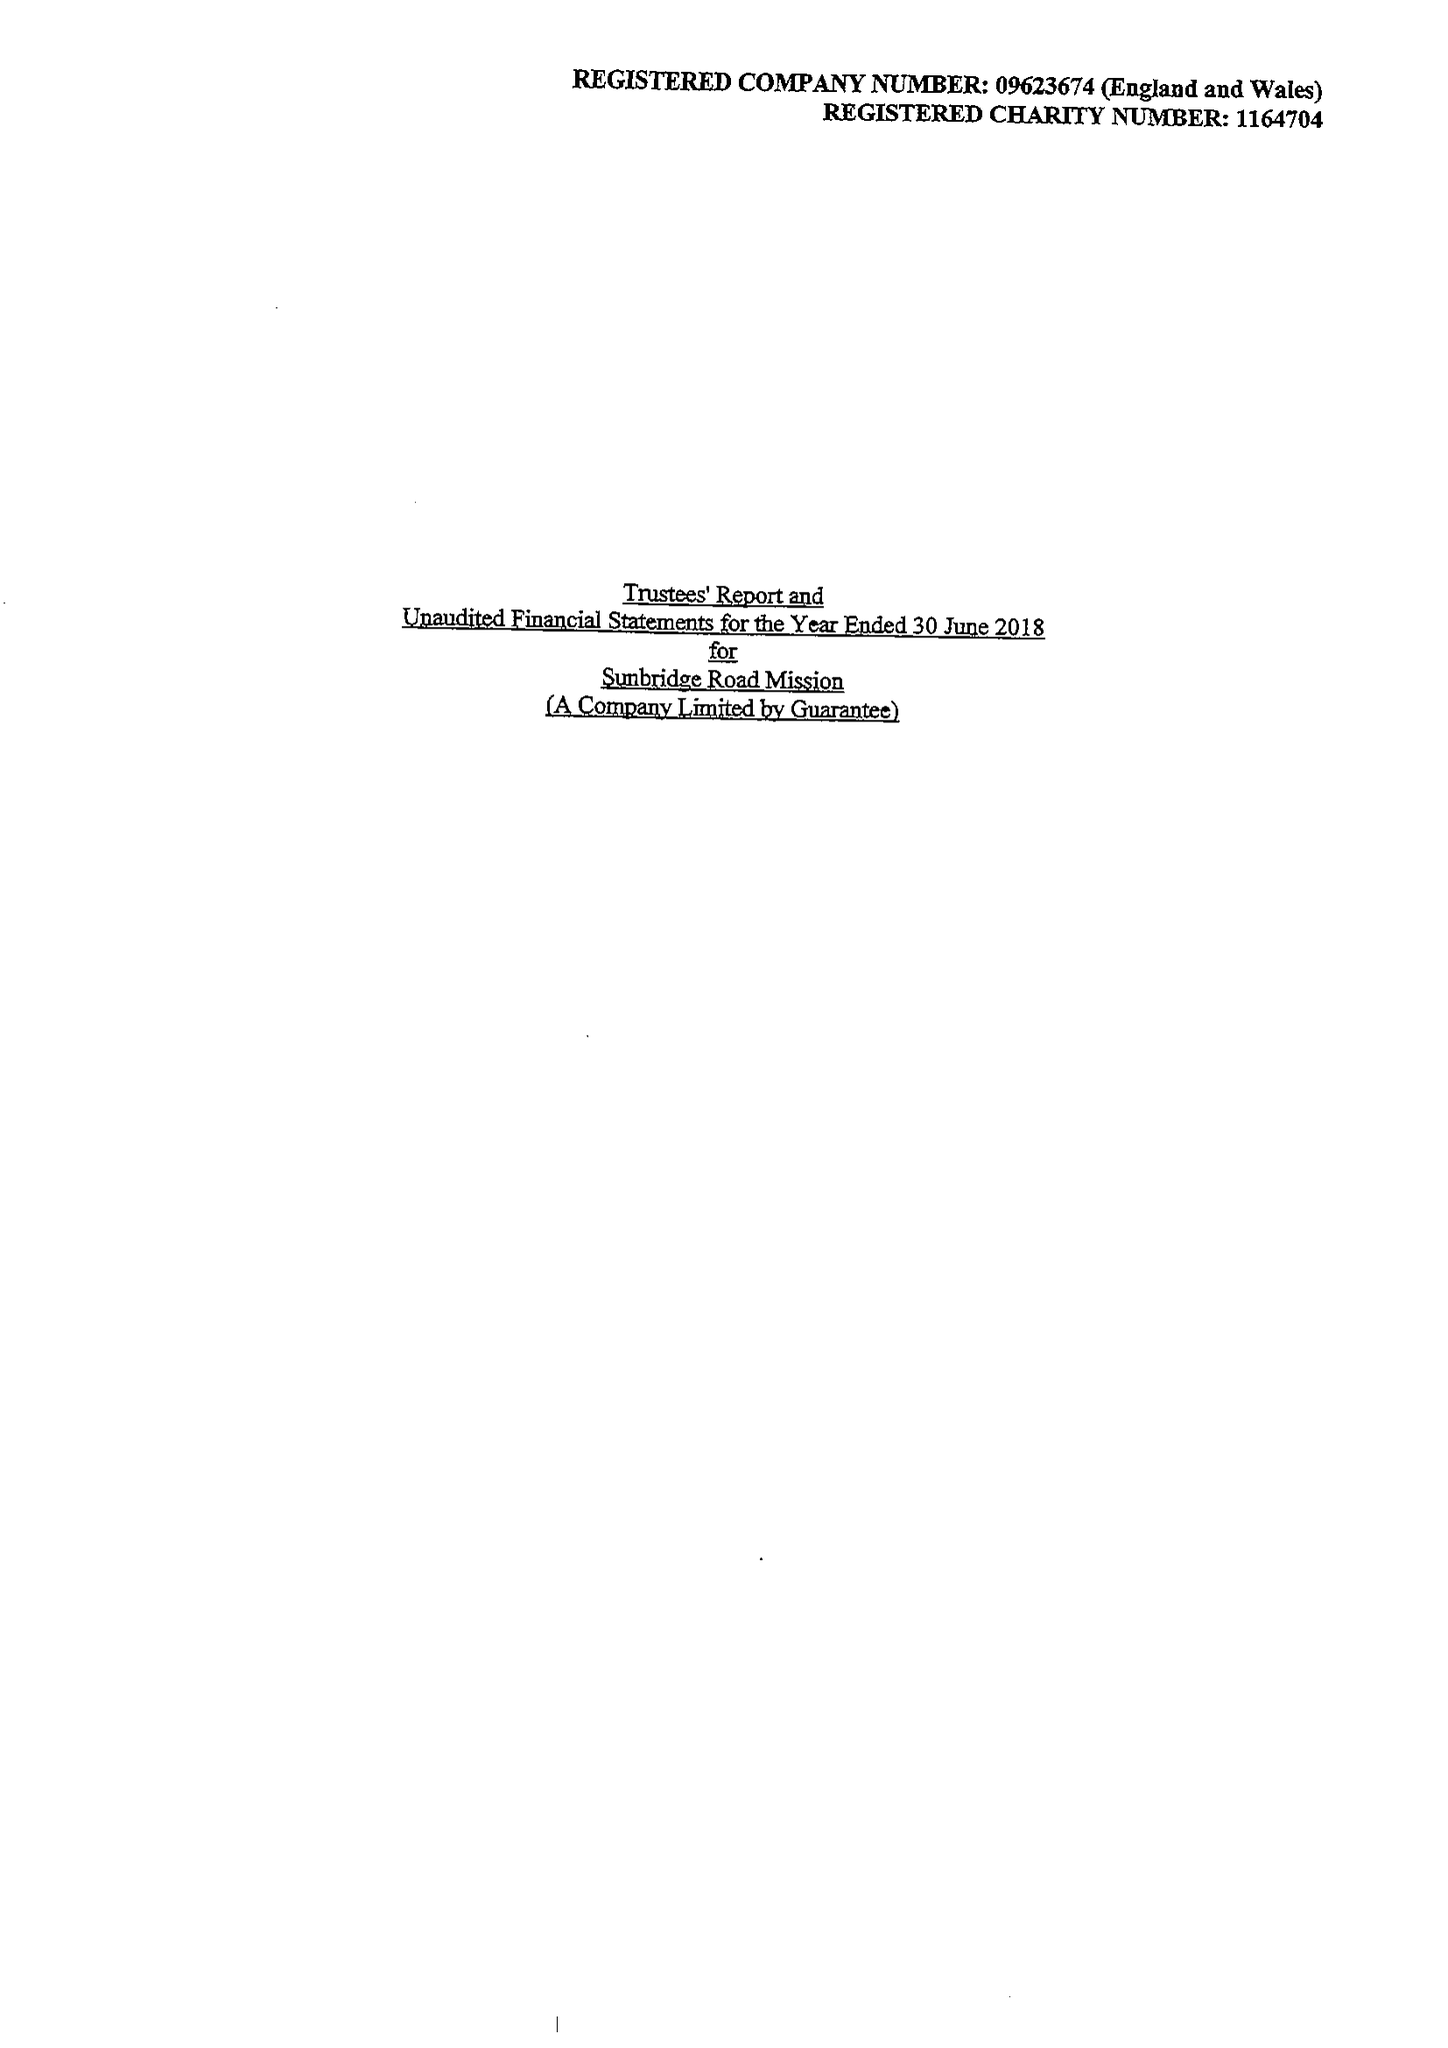What is the value for the report_date?
Answer the question using a single word or phrase. 2018-06-30 